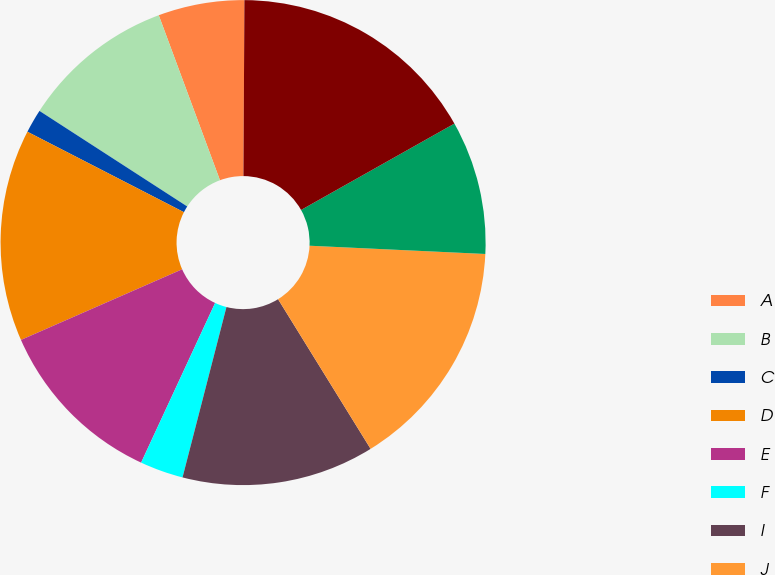Convert chart. <chart><loc_0><loc_0><loc_500><loc_500><pie_chart><fcel>A<fcel>B<fcel>C<fcel>D<fcel>E<fcel>F<fcel>I<fcel>J<fcel>K<fcel>L<nl><fcel>5.74%<fcel>10.21%<fcel>1.58%<fcel>14.13%<fcel>11.52%<fcel>2.89%<fcel>12.83%<fcel>15.44%<fcel>8.91%<fcel>16.75%<nl></chart> 